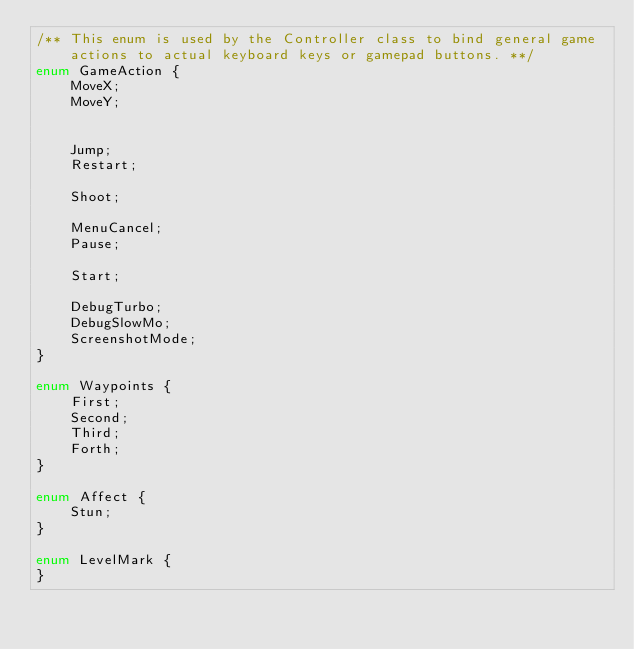Convert code to text. <code><loc_0><loc_0><loc_500><loc_500><_Haxe_>/**	This enum is used by the Controller class to bind general game actions to actual keyboard keys or gamepad buttons. **/
enum GameAction {
	MoveX;
	MoveY;


	Jump;
	Restart;

	Shoot;

	MenuCancel;
	Pause;

	Start;

	DebugTurbo;
	DebugSlowMo;
	ScreenshotMode;
}

enum Waypoints {
	First;
	Second;
	Third;
	Forth;
}

enum Affect {
	Stun;
}

enum LevelMark {
}</code> 